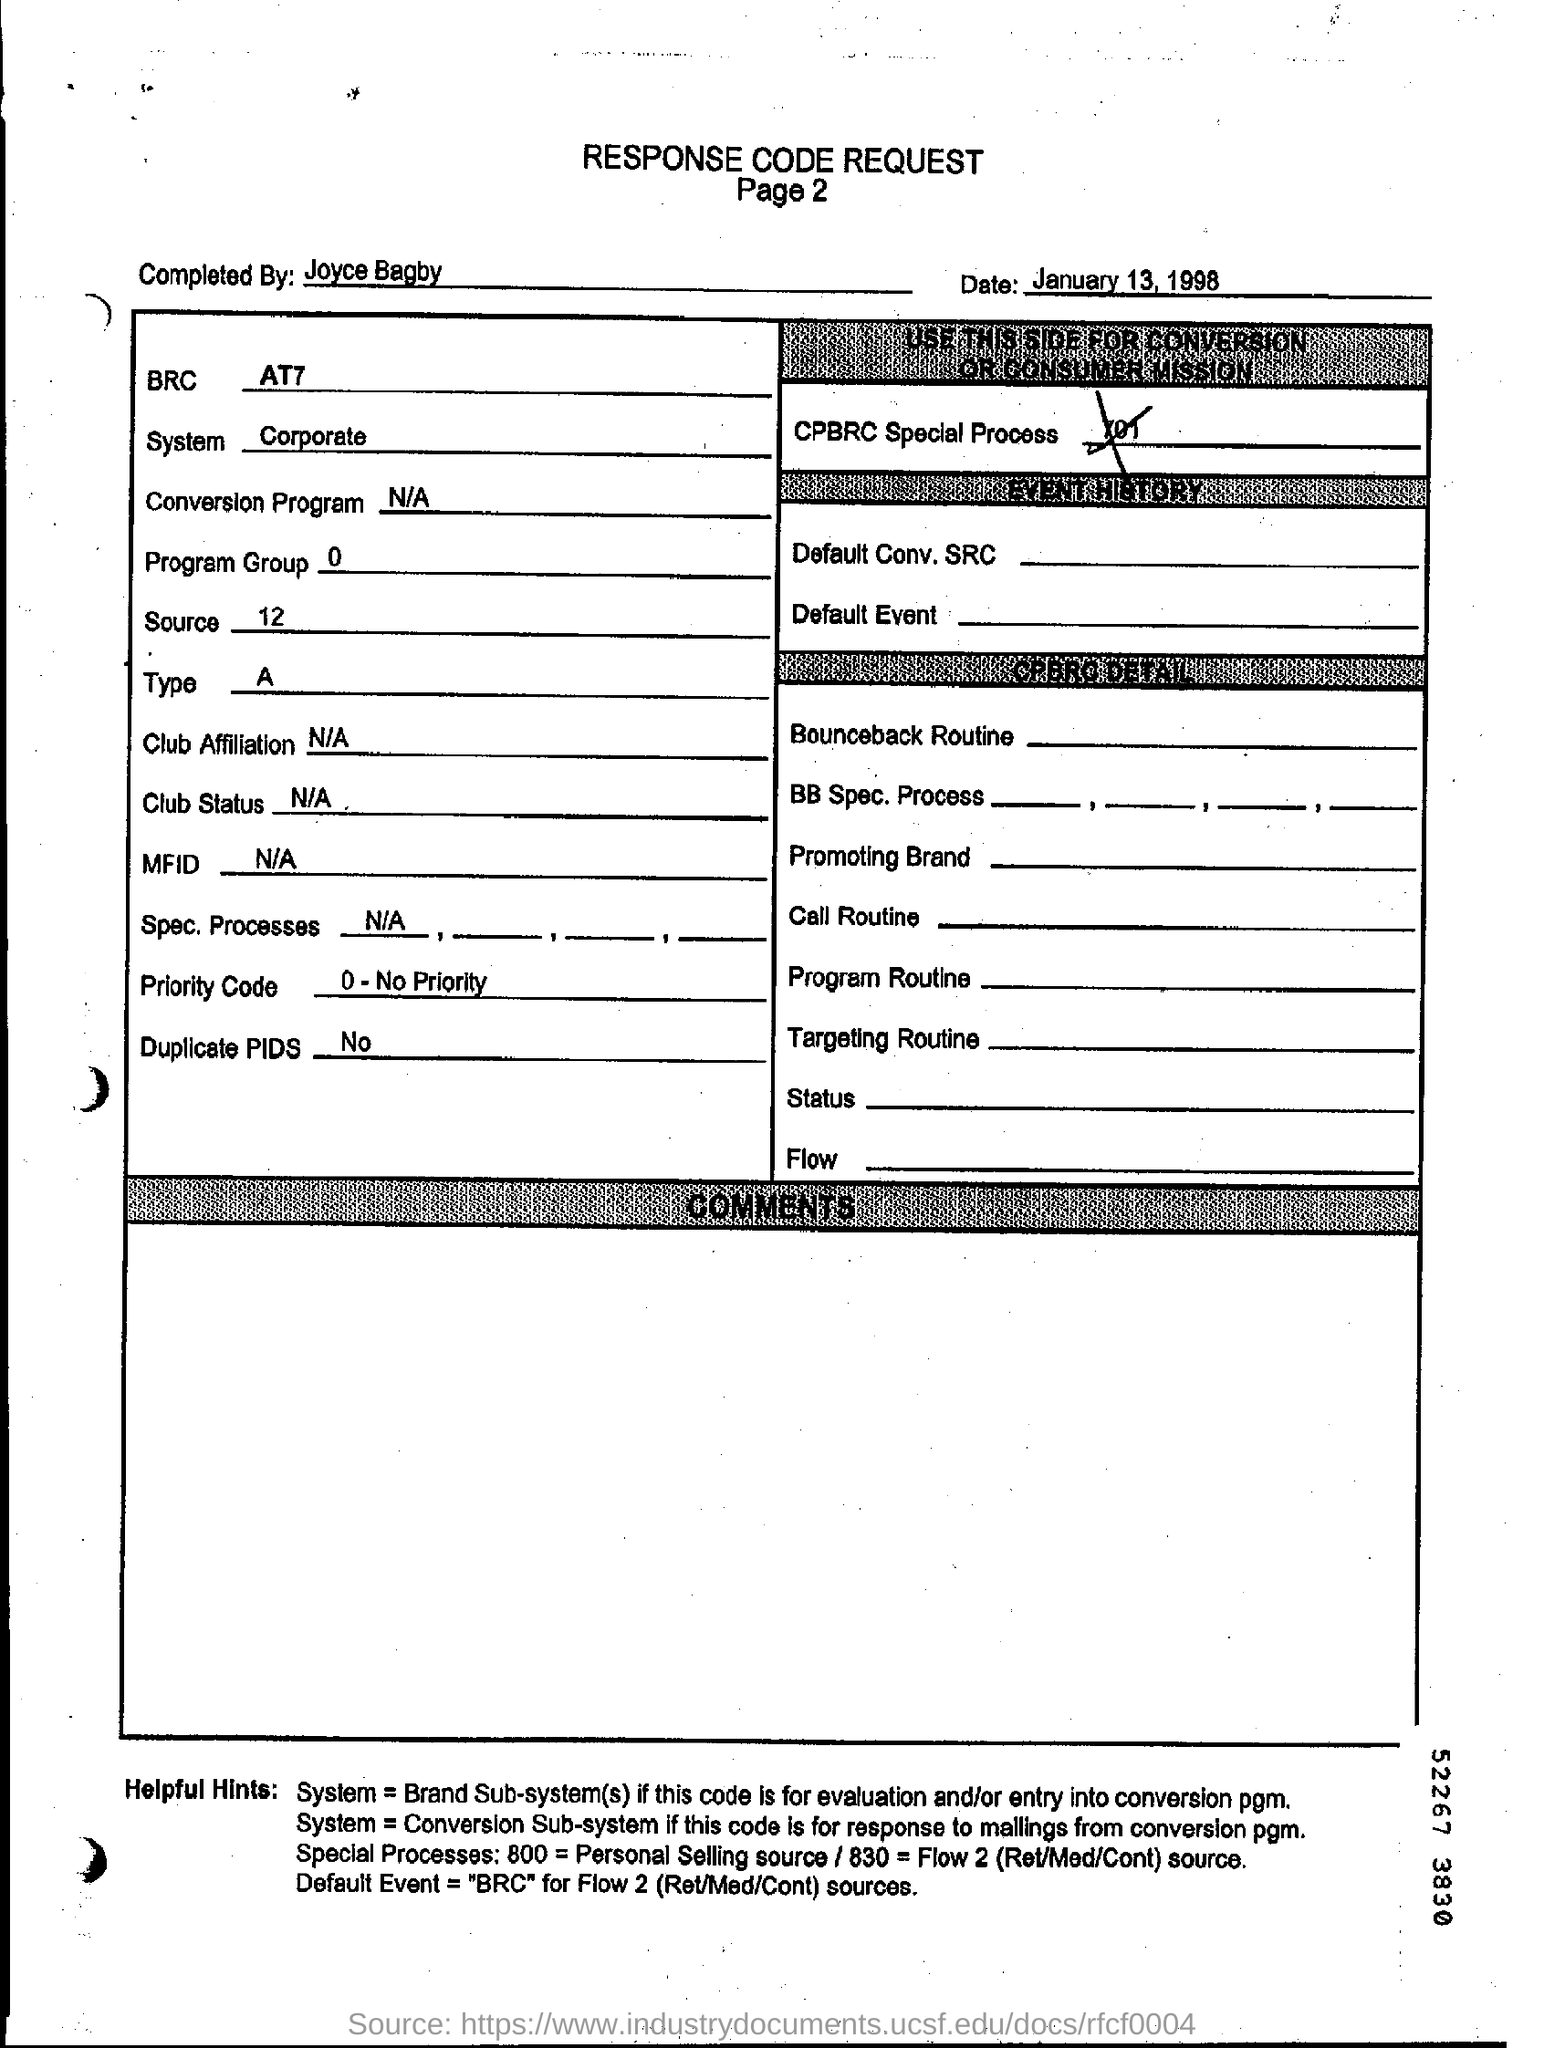Point out several critical features in this image. The response code request was dated January 13, 1998. Please mention the page number below your response code request, thank you. 